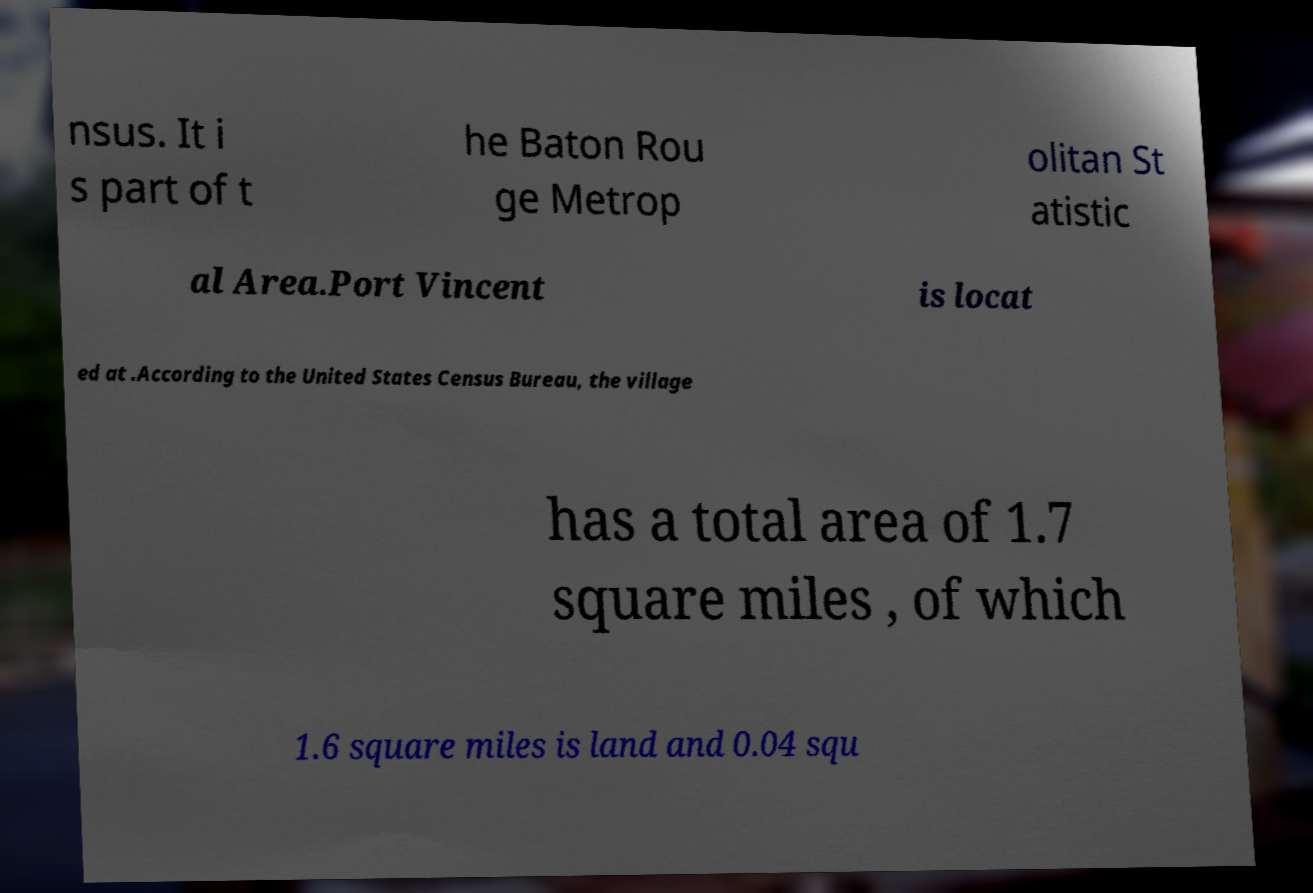Please read and relay the text visible in this image. What does it say? nsus. It i s part of t he Baton Rou ge Metrop olitan St atistic al Area.Port Vincent is locat ed at .According to the United States Census Bureau, the village has a total area of 1.7 square miles , of which 1.6 square miles is land and 0.04 squ 